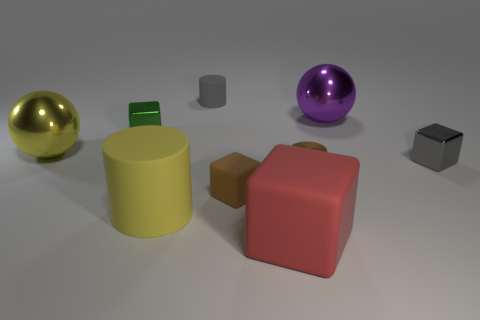Subtract all large yellow matte cylinders. How many cylinders are left? 2 Add 1 brown cylinders. How many objects exist? 10 Subtract all purple balls. How many balls are left? 1 Subtract 3 cubes. How many cubes are left? 1 Subtract all blocks. How many objects are left? 5 Subtract all brown cubes. Subtract all blue spheres. How many cubes are left? 3 Subtract all blue balls. Subtract all brown matte blocks. How many objects are left? 8 Add 3 tiny things. How many tiny things are left? 8 Add 2 tiny cubes. How many tiny cubes exist? 5 Subtract 1 brown cubes. How many objects are left? 8 